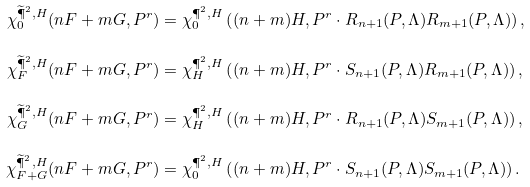Convert formula to latex. <formula><loc_0><loc_0><loc_500><loc_500>\chi ^ { \widetilde { \P } ^ { 2 } , H } _ { 0 } ( n F + m G , P ^ { r } ) & = \chi ^ { \P ^ { 2 } , H } _ { 0 } \left ( ( n + m ) H , P ^ { r } \cdot R _ { n + 1 } ( P , \Lambda ) R _ { m + 1 } ( P , \Lambda ) \right ) , \\ \chi ^ { \widetilde { \P } ^ { 2 } , H } _ { F } ( n F + m G , P ^ { r } ) & = \chi ^ { \P ^ { 2 } , H } _ { H } \left ( ( n + m ) H , P ^ { r } \cdot S _ { n + 1 } ( P , \Lambda ) R _ { m + 1 } ( P , \Lambda ) \right ) , \\ \chi ^ { \widetilde { \P } ^ { 2 } , H } _ { G } ( n F + m G , P ^ { r } ) & = \chi ^ { \P ^ { 2 } , H } _ { H } \left ( ( n + m ) H , P ^ { r } \cdot R _ { n + 1 } ( P , \Lambda ) S _ { m + 1 } ( P , \Lambda ) \right ) , \\ \chi ^ { \widetilde { \P } ^ { 2 } , H } _ { F + G } ( n F + m G , P ^ { r } ) & = \chi ^ { \P ^ { 2 } , H } _ { 0 } \left ( ( n + m ) H , P ^ { r } \cdot S _ { n + 1 } ( P , \Lambda ) S _ { m + 1 } ( P , \Lambda ) \right ) .</formula> 